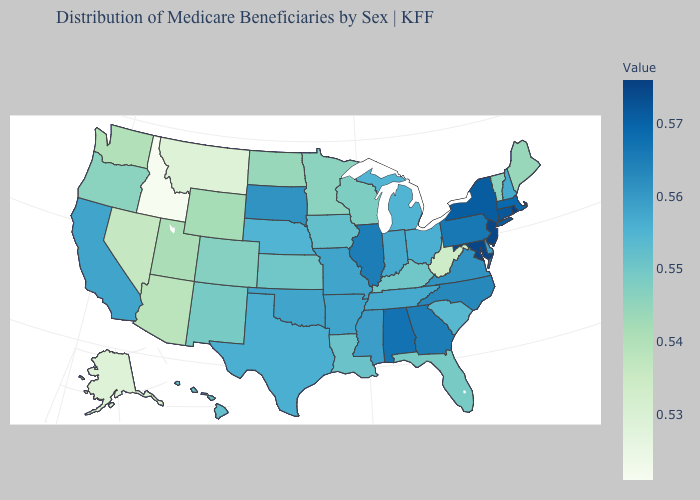Does the map have missing data?
Be succinct. No. Among the states that border Nebraska , does Wyoming have the lowest value?
Concise answer only. Yes. Does Louisiana have a higher value than Mississippi?
Short answer required. No. Does Texas have a lower value than Rhode Island?
Concise answer only. Yes. Does Rhode Island have the highest value in the USA?
Quick response, please. Yes. Among the states that border Idaho , which have the lowest value?
Quick response, please. Montana. 